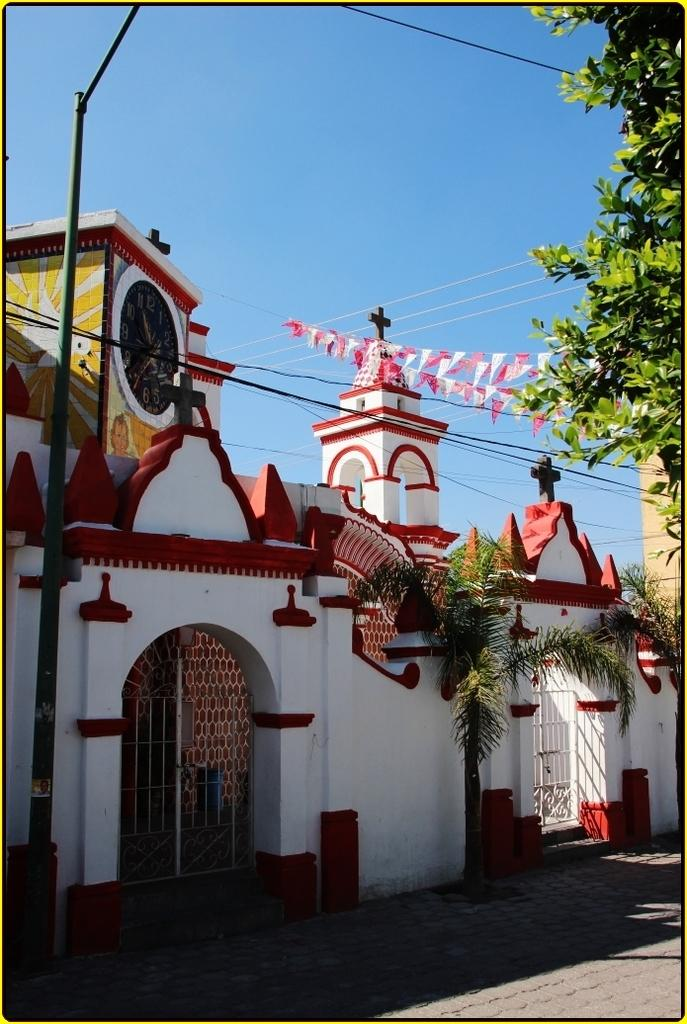What is the color of the wall in the image? The wall in the image is white. What structures can be seen in the image? There is a gate, a clock tower, and a pole in the image. What else is visible in the image besides the structures? Wires, trees, and decoration flags are present in the image. What is the color of the sky in the background? The sky in the background is blue. How many quinces are hanging from the pole in the image? There are no quinces present in the image; the pole is not associated with any fruits. 